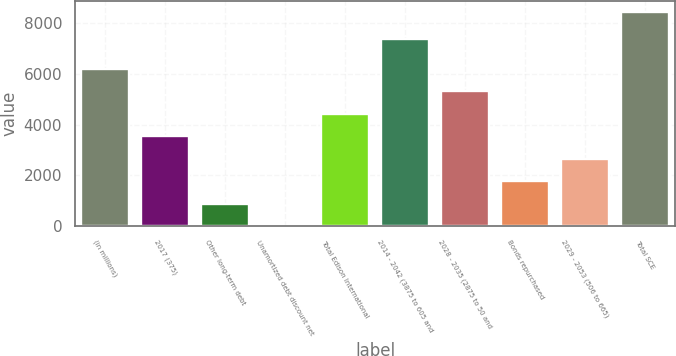Convert chart. <chart><loc_0><loc_0><loc_500><loc_500><bar_chart><fcel>(in millions)<fcel>2017 (375)<fcel>Other long-term debt<fcel>Unamortized debt discount net<fcel>Total Edison International<fcel>2014 - 2042 (3875 to 605 and<fcel>2028 - 2035 (2875 to 50 and<fcel>Bonds repurchased<fcel>2029 - 2053 (506 to 665)<fcel>Total SCE<nl><fcel>6184.1<fcel>3534.2<fcel>884.3<fcel>1<fcel>4417.5<fcel>7375<fcel>5300.8<fcel>1767.6<fcel>2650.9<fcel>8431<nl></chart> 